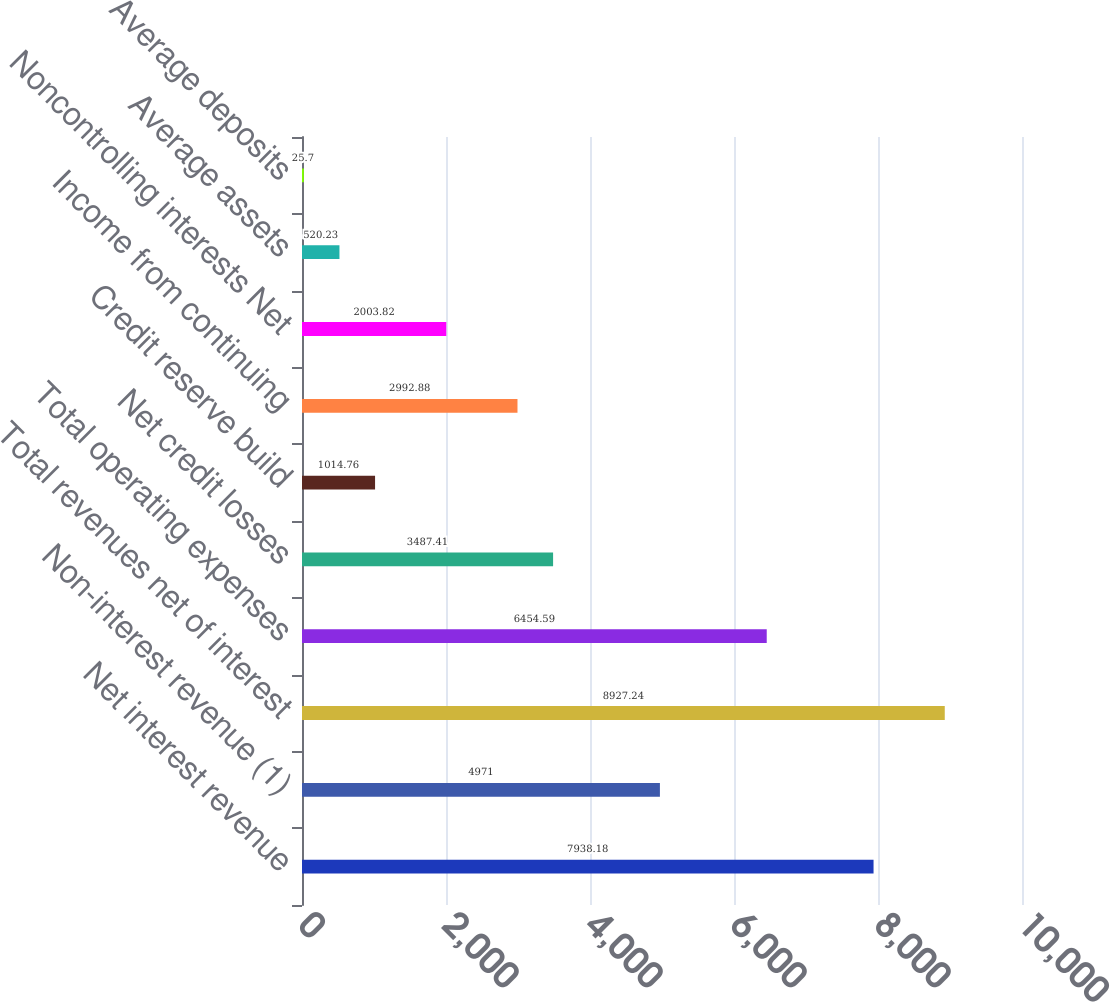<chart> <loc_0><loc_0><loc_500><loc_500><bar_chart><fcel>Net interest revenue<fcel>Non-interest revenue (1)<fcel>Total revenues net of interest<fcel>Total operating expenses<fcel>Net credit losses<fcel>Credit reserve build<fcel>Income from continuing<fcel>Noncontrolling interests Net<fcel>Average assets<fcel>Average deposits<nl><fcel>7938.18<fcel>4971<fcel>8927.24<fcel>6454.59<fcel>3487.41<fcel>1014.76<fcel>2992.88<fcel>2003.82<fcel>520.23<fcel>25.7<nl></chart> 